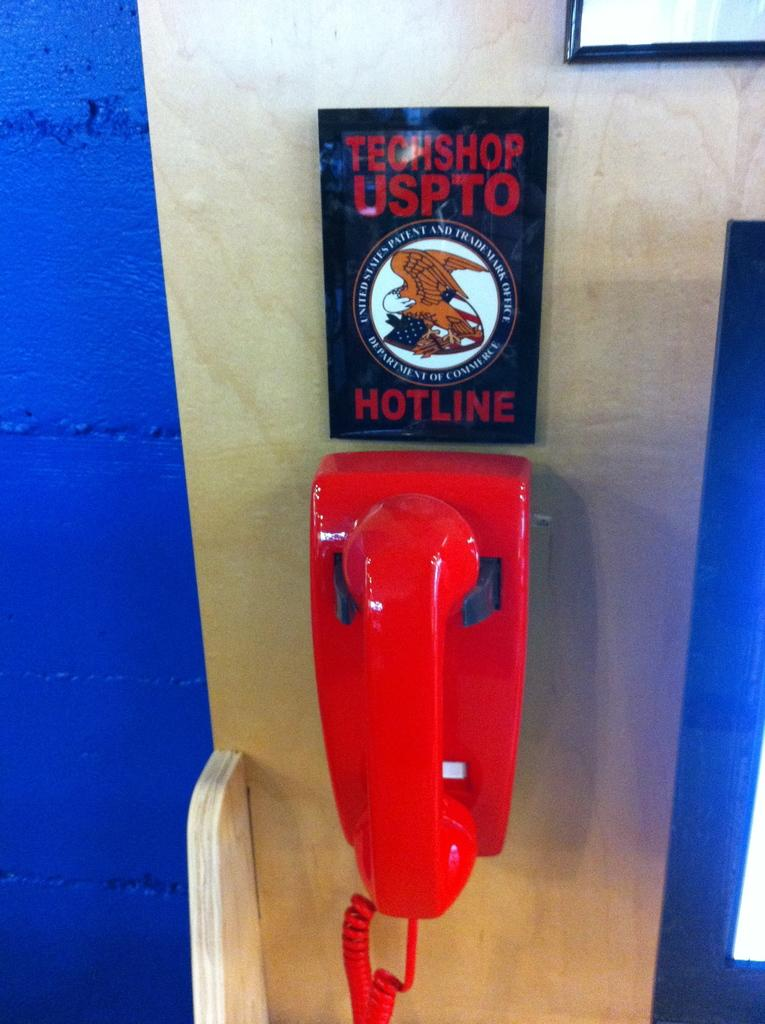Provide a one-sentence caption for the provided image. An old fashoined red phone hangs on wall below a sign which says Technoshop Uspto Hotline. 